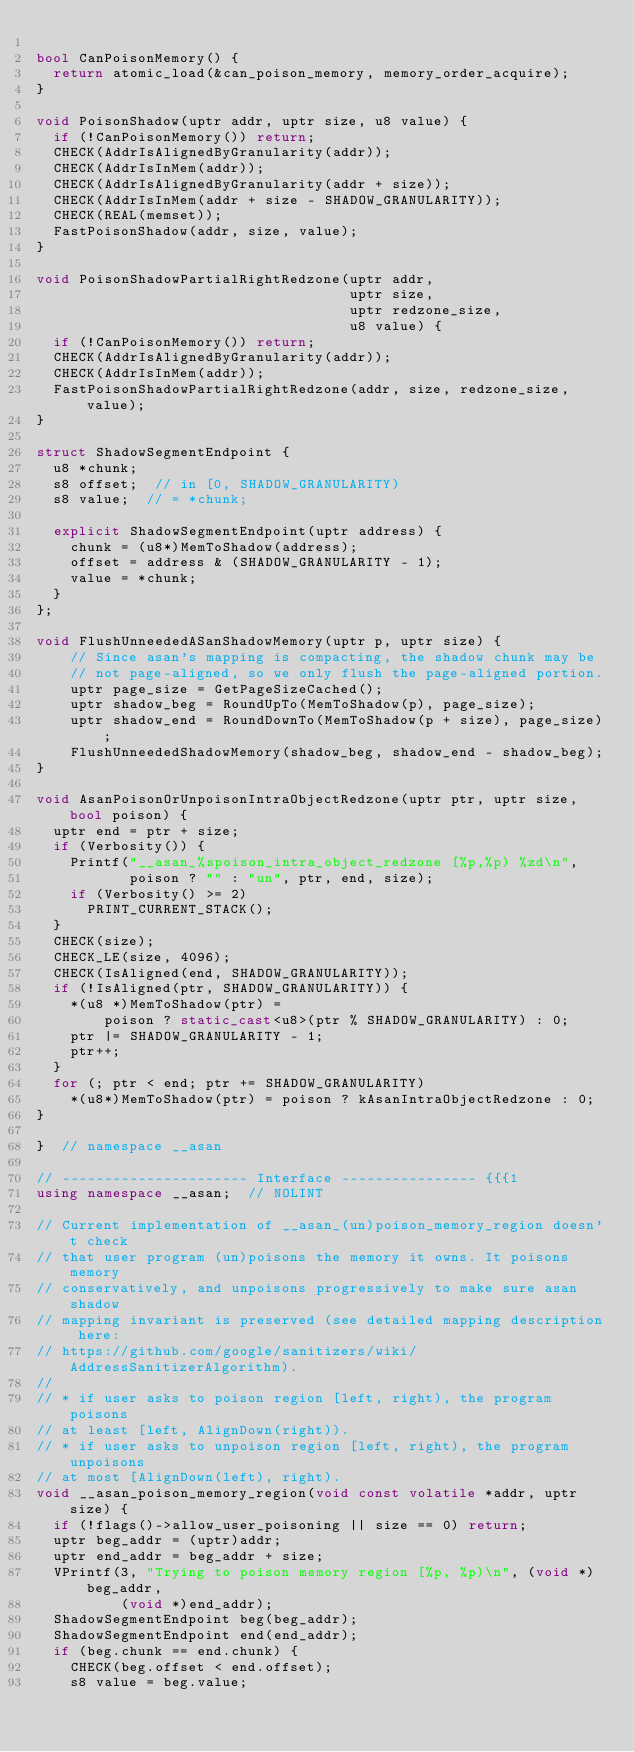<code> <loc_0><loc_0><loc_500><loc_500><_C++_>
bool CanPoisonMemory() {
  return atomic_load(&can_poison_memory, memory_order_acquire);
}

void PoisonShadow(uptr addr, uptr size, u8 value) {
  if (!CanPoisonMemory()) return;
  CHECK(AddrIsAlignedByGranularity(addr));
  CHECK(AddrIsInMem(addr));
  CHECK(AddrIsAlignedByGranularity(addr + size));
  CHECK(AddrIsInMem(addr + size - SHADOW_GRANULARITY));
  CHECK(REAL(memset));
  FastPoisonShadow(addr, size, value);
}

void PoisonShadowPartialRightRedzone(uptr addr,
                                     uptr size,
                                     uptr redzone_size,
                                     u8 value) {
  if (!CanPoisonMemory()) return;
  CHECK(AddrIsAlignedByGranularity(addr));
  CHECK(AddrIsInMem(addr));
  FastPoisonShadowPartialRightRedzone(addr, size, redzone_size, value);
}

struct ShadowSegmentEndpoint {
  u8 *chunk;
  s8 offset;  // in [0, SHADOW_GRANULARITY)
  s8 value;  // = *chunk;

  explicit ShadowSegmentEndpoint(uptr address) {
    chunk = (u8*)MemToShadow(address);
    offset = address & (SHADOW_GRANULARITY - 1);
    value = *chunk;
  }
};

void FlushUnneededASanShadowMemory(uptr p, uptr size) {
    // Since asan's mapping is compacting, the shadow chunk may be
    // not page-aligned, so we only flush the page-aligned portion.
    uptr page_size = GetPageSizeCached();
    uptr shadow_beg = RoundUpTo(MemToShadow(p), page_size);
    uptr shadow_end = RoundDownTo(MemToShadow(p + size), page_size);
    FlushUnneededShadowMemory(shadow_beg, shadow_end - shadow_beg);
}

void AsanPoisonOrUnpoisonIntraObjectRedzone(uptr ptr, uptr size, bool poison) {
  uptr end = ptr + size;
  if (Verbosity()) {
    Printf("__asan_%spoison_intra_object_redzone [%p,%p) %zd\n",
           poison ? "" : "un", ptr, end, size);
    if (Verbosity() >= 2)
      PRINT_CURRENT_STACK();
  }
  CHECK(size);
  CHECK_LE(size, 4096);
  CHECK(IsAligned(end, SHADOW_GRANULARITY));
  if (!IsAligned(ptr, SHADOW_GRANULARITY)) {
    *(u8 *)MemToShadow(ptr) =
        poison ? static_cast<u8>(ptr % SHADOW_GRANULARITY) : 0;
    ptr |= SHADOW_GRANULARITY - 1;
    ptr++;
  }
  for (; ptr < end; ptr += SHADOW_GRANULARITY)
    *(u8*)MemToShadow(ptr) = poison ? kAsanIntraObjectRedzone : 0;
}

}  // namespace __asan

// ---------------------- Interface ---------------- {{{1
using namespace __asan;  // NOLINT

// Current implementation of __asan_(un)poison_memory_region doesn't check
// that user program (un)poisons the memory it owns. It poisons memory
// conservatively, and unpoisons progressively to make sure asan shadow
// mapping invariant is preserved (see detailed mapping description here:
// https://github.com/google/sanitizers/wiki/AddressSanitizerAlgorithm).
//
// * if user asks to poison region [left, right), the program poisons
// at least [left, AlignDown(right)).
// * if user asks to unpoison region [left, right), the program unpoisons
// at most [AlignDown(left), right).
void __asan_poison_memory_region(void const volatile *addr, uptr size) {
  if (!flags()->allow_user_poisoning || size == 0) return;
  uptr beg_addr = (uptr)addr;
  uptr end_addr = beg_addr + size;
  VPrintf(3, "Trying to poison memory region [%p, %p)\n", (void *)beg_addr,
          (void *)end_addr);
  ShadowSegmentEndpoint beg(beg_addr);
  ShadowSegmentEndpoint end(end_addr);
  if (beg.chunk == end.chunk) {
    CHECK(beg.offset < end.offset);
    s8 value = beg.value;</code> 